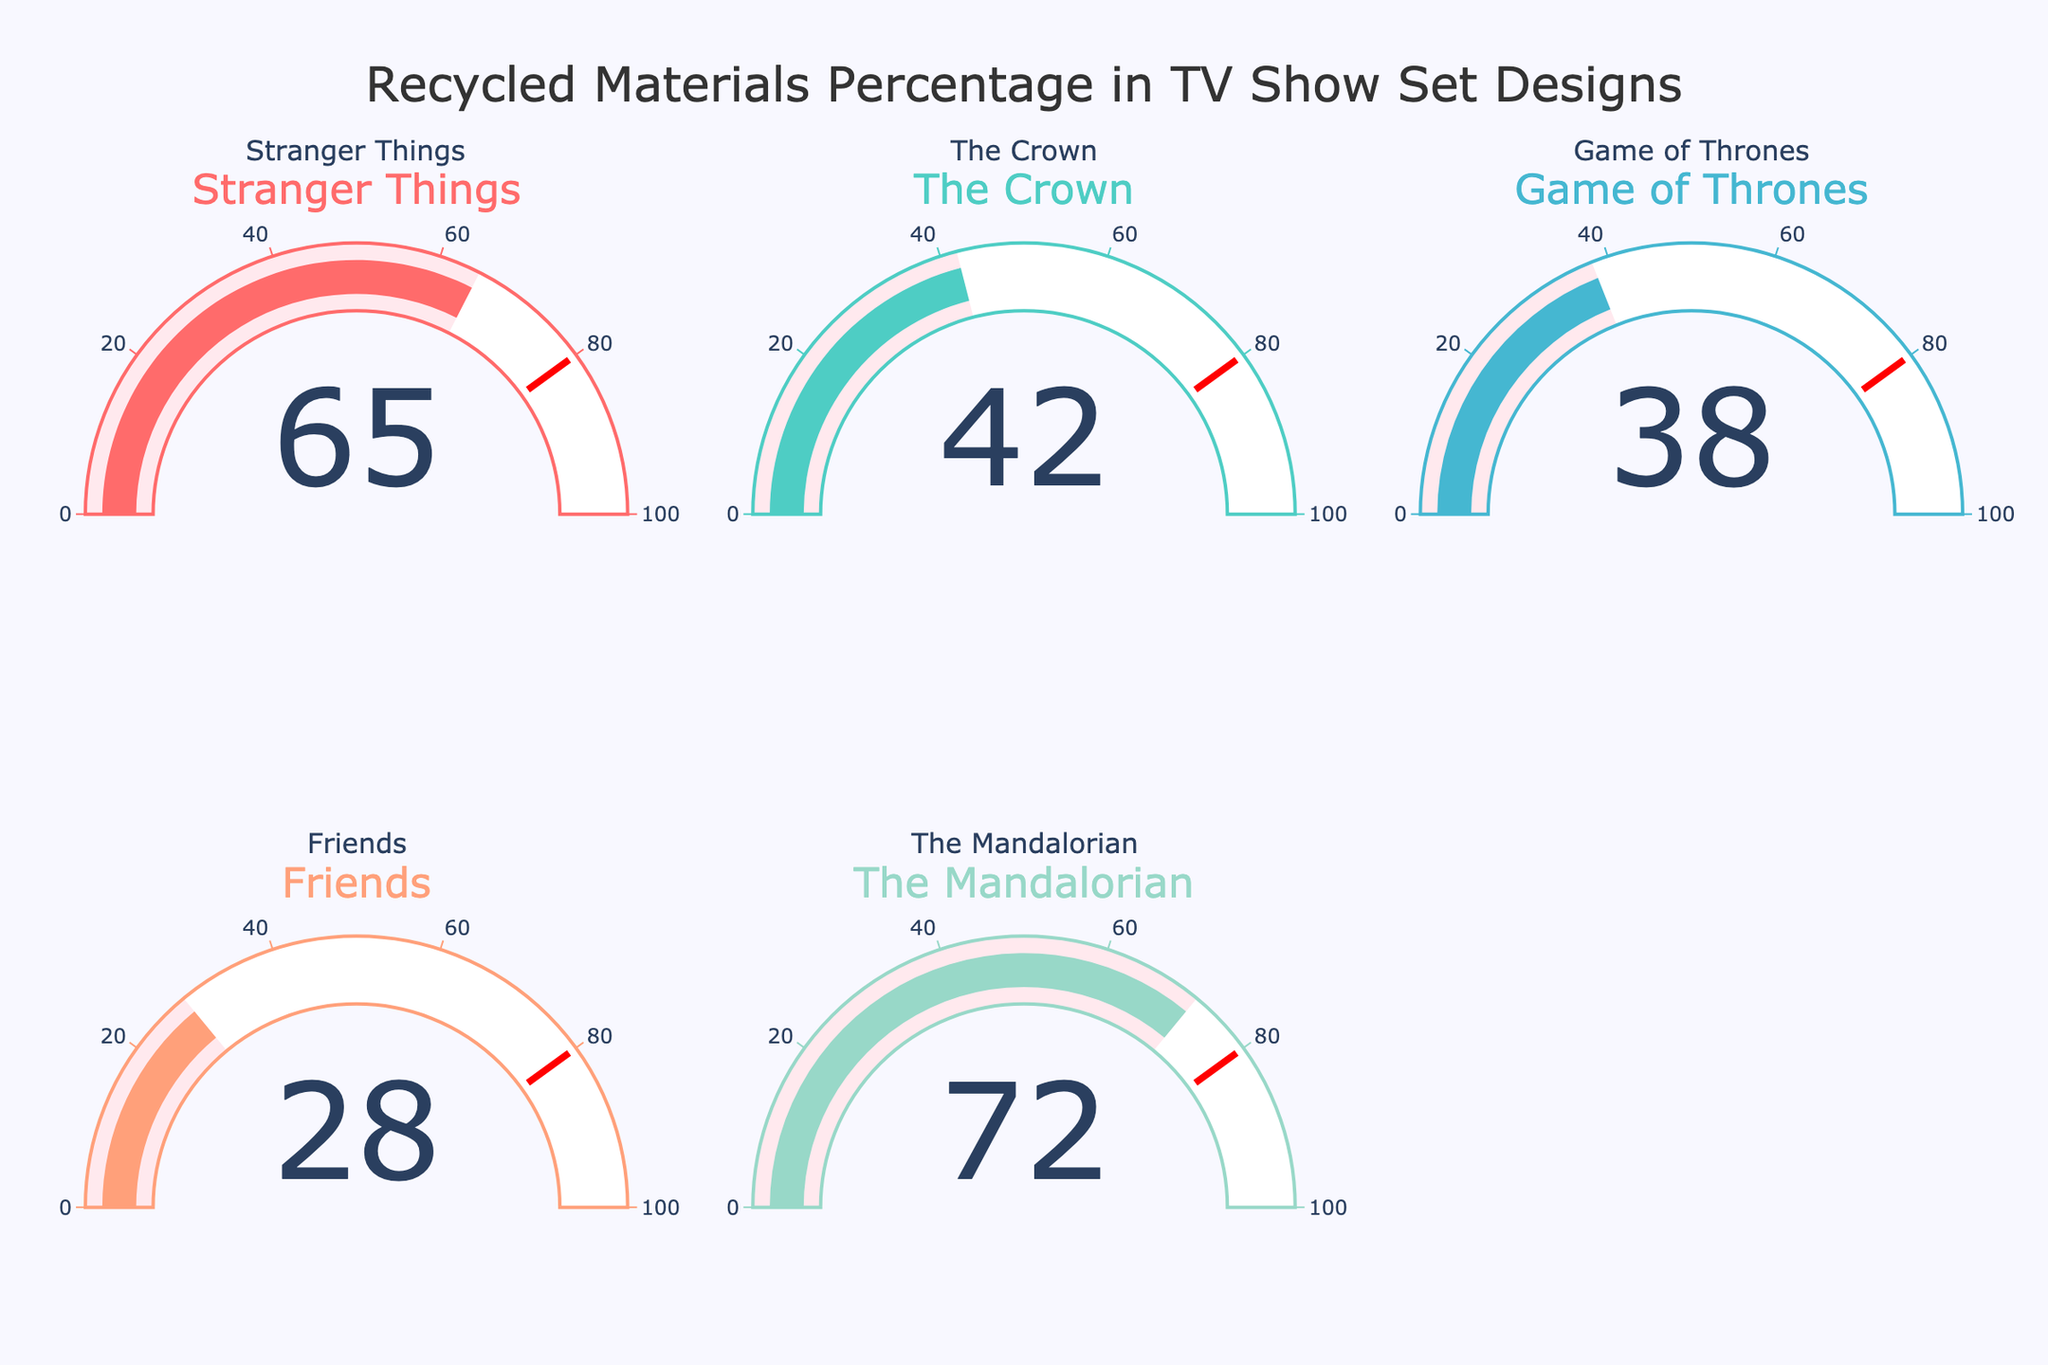What's the highest percentage of recycled materials used? Look at each gauge and identify the one showing the highest value. The Mandalorian shows a value of 72%, which is the highest.
Answer: 72% Which TV show used the least amount of recycled materials? Compare the percentages shown on each gauge. Friends has the lowest value at 28%.
Answer: Friends What is the average percentage of recycled materials used across all shows? Sum the percentages (65 + 42 + 38 + 28 + 72) and divide by the number of TV shows (5). The sum is 245, so the average is 245/5 = 49.
Answer: 49 How many TV shows have a recycled materials percentage above 50%? Identify the gauges with values above 50%. Stranger Things (65%) and The Mandalorian (72%) are above 50%, so there are 2 shows.
Answer: 2 Which show has a recycled materials percentage closest to 40%? Compare each percentage to 40% and find the closest one. The Crown at 42% is closest to 40%.
Answer: The Crown What's the difference in recycled materials percentage between Stranger Things and Game of Thrones? Subtract the percentage of Game of Thrones (38%) from that of Stranger Things (65%). 65 - 38 = 27.
Answer: 27 Are there any shows with an exact match for the threshold value depicted by the red line in the gauge? The red line represents a threshold value of 80%. Scan all gauges to see if any values match 80%. None of the gauges have a value of 80%.
Answer: No Is the majority of the TV shows' recycled material percentages above or below 50%? There are 5 shows in total. Assess each percentage: 3 values are below 50% (42%, 38%, 28%) and 2 are above (65%, 72%). Majority indicates more than half, so below 50% is the majority.
Answer: Below 